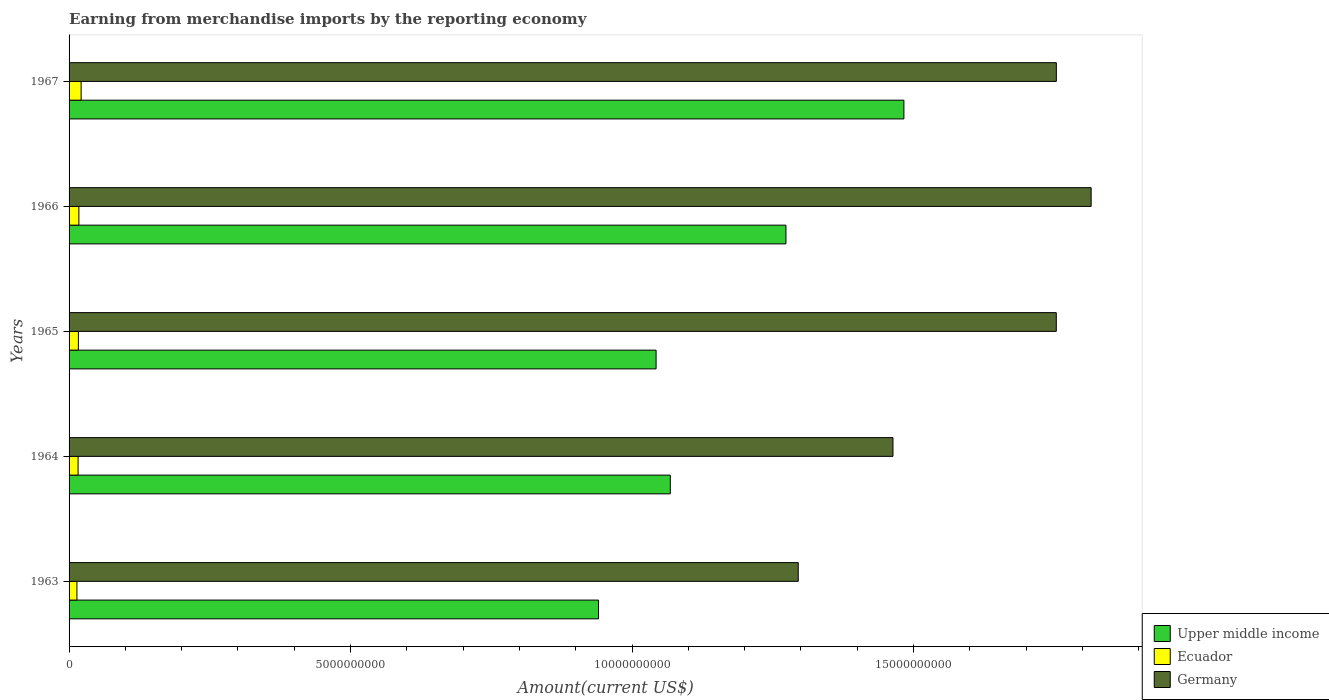How many different coloured bars are there?
Your response must be concise. 3. Are the number of bars per tick equal to the number of legend labels?
Provide a short and direct response. Yes. Are the number of bars on each tick of the Y-axis equal?
Offer a very short reply. Yes. How many bars are there on the 2nd tick from the top?
Provide a succinct answer. 3. How many bars are there on the 4th tick from the bottom?
Your answer should be compact. 3. What is the label of the 4th group of bars from the top?
Offer a very short reply. 1964. In how many cases, is the number of bars for a given year not equal to the number of legend labels?
Ensure brevity in your answer.  0. What is the amount earned from merchandise imports in Germany in 1966?
Your response must be concise. 1.82e+1. Across all years, what is the maximum amount earned from merchandise imports in Ecuador?
Make the answer very short. 2.14e+08. Across all years, what is the minimum amount earned from merchandise imports in Upper middle income?
Provide a succinct answer. 9.40e+09. In which year was the amount earned from merchandise imports in Ecuador maximum?
Your answer should be compact. 1967. In which year was the amount earned from merchandise imports in Upper middle income minimum?
Make the answer very short. 1963. What is the total amount earned from merchandise imports in Germany in the graph?
Offer a terse response. 8.08e+1. What is the difference between the amount earned from merchandise imports in Upper middle income in 1964 and that in 1966?
Offer a terse response. -2.05e+09. What is the difference between the amount earned from merchandise imports in Germany in 1966 and the amount earned from merchandise imports in Upper middle income in 1963?
Make the answer very short. 8.75e+09. What is the average amount earned from merchandise imports in Upper middle income per year?
Your answer should be very brief. 1.16e+1. In the year 1967, what is the difference between the amount earned from merchandise imports in Upper middle income and amount earned from merchandise imports in Ecuador?
Provide a short and direct response. 1.46e+1. In how many years, is the amount earned from merchandise imports in Germany greater than 8000000000 US$?
Make the answer very short. 5. What is the ratio of the amount earned from merchandise imports in Germany in 1963 to that in 1964?
Offer a terse response. 0.89. Is the amount earned from merchandise imports in Ecuador in 1964 less than that in 1966?
Provide a short and direct response. Yes. Is the difference between the amount earned from merchandise imports in Upper middle income in 1963 and 1964 greater than the difference between the amount earned from merchandise imports in Ecuador in 1963 and 1964?
Keep it short and to the point. No. What is the difference between the highest and the second highest amount earned from merchandise imports in Upper middle income?
Provide a succinct answer. 2.10e+09. What is the difference between the highest and the lowest amount earned from merchandise imports in Upper middle income?
Your response must be concise. 5.42e+09. Is the sum of the amount earned from merchandise imports in Germany in 1964 and 1965 greater than the maximum amount earned from merchandise imports in Upper middle income across all years?
Keep it short and to the point. Yes. What does the 3rd bar from the top in 1966 represents?
Your response must be concise. Upper middle income. What does the 3rd bar from the bottom in 1963 represents?
Offer a very short reply. Germany. Is it the case that in every year, the sum of the amount earned from merchandise imports in Ecuador and amount earned from merchandise imports in Germany is greater than the amount earned from merchandise imports in Upper middle income?
Ensure brevity in your answer.  Yes. Are all the bars in the graph horizontal?
Ensure brevity in your answer.  Yes. How many years are there in the graph?
Provide a succinct answer. 5. What is the difference between two consecutive major ticks on the X-axis?
Keep it short and to the point. 5.00e+09. How many legend labels are there?
Provide a succinct answer. 3. How are the legend labels stacked?
Offer a very short reply. Vertical. What is the title of the graph?
Provide a short and direct response. Earning from merchandise imports by the reporting economy. Does "Europe(all income levels)" appear as one of the legend labels in the graph?
Keep it short and to the point. No. What is the label or title of the X-axis?
Offer a very short reply. Amount(current US$). What is the label or title of the Y-axis?
Ensure brevity in your answer.  Years. What is the Amount(current US$) of Upper middle income in 1963?
Offer a terse response. 9.40e+09. What is the Amount(current US$) in Ecuador in 1963?
Offer a terse response. 1.39e+08. What is the Amount(current US$) in Germany in 1963?
Your answer should be very brief. 1.30e+1. What is the Amount(current US$) in Upper middle income in 1964?
Provide a succinct answer. 1.07e+1. What is the Amount(current US$) of Ecuador in 1964?
Your response must be concise. 1.60e+08. What is the Amount(current US$) in Germany in 1964?
Make the answer very short. 1.46e+1. What is the Amount(current US$) in Upper middle income in 1965?
Your response must be concise. 1.04e+1. What is the Amount(current US$) of Ecuador in 1965?
Give a very brief answer. 1.65e+08. What is the Amount(current US$) in Germany in 1965?
Provide a short and direct response. 1.75e+1. What is the Amount(current US$) in Upper middle income in 1966?
Offer a very short reply. 1.27e+1. What is the Amount(current US$) in Ecuador in 1966?
Ensure brevity in your answer.  1.74e+08. What is the Amount(current US$) of Germany in 1966?
Your response must be concise. 1.82e+1. What is the Amount(current US$) in Upper middle income in 1967?
Your answer should be compact. 1.48e+1. What is the Amount(current US$) of Ecuador in 1967?
Make the answer very short. 2.14e+08. What is the Amount(current US$) of Germany in 1967?
Provide a short and direct response. 1.75e+1. Across all years, what is the maximum Amount(current US$) in Upper middle income?
Your answer should be very brief. 1.48e+1. Across all years, what is the maximum Amount(current US$) in Ecuador?
Make the answer very short. 2.14e+08. Across all years, what is the maximum Amount(current US$) in Germany?
Your answer should be compact. 1.82e+1. Across all years, what is the minimum Amount(current US$) of Upper middle income?
Make the answer very short. 9.40e+09. Across all years, what is the minimum Amount(current US$) in Ecuador?
Offer a very short reply. 1.39e+08. Across all years, what is the minimum Amount(current US$) of Germany?
Provide a succinct answer. 1.30e+1. What is the total Amount(current US$) of Upper middle income in the graph?
Keep it short and to the point. 5.81e+1. What is the total Amount(current US$) in Ecuador in the graph?
Offer a very short reply. 8.53e+08. What is the total Amount(current US$) in Germany in the graph?
Make the answer very short. 8.08e+1. What is the difference between the Amount(current US$) of Upper middle income in 1963 and that in 1964?
Your response must be concise. -1.27e+09. What is the difference between the Amount(current US$) of Ecuador in 1963 and that in 1964?
Offer a terse response. -2.07e+07. What is the difference between the Amount(current US$) in Germany in 1963 and that in 1964?
Your answer should be compact. -1.68e+09. What is the difference between the Amount(current US$) in Upper middle income in 1963 and that in 1965?
Give a very brief answer. -1.02e+09. What is the difference between the Amount(current US$) in Ecuador in 1963 and that in 1965?
Provide a short and direct response. -2.60e+07. What is the difference between the Amount(current US$) of Germany in 1963 and that in 1965?
Your response must be concise. -4.58e+09. What is the difference between the Amount(current US$) in Upper middle income in 1963 and that in 1966?
Provide a succinct answer. -3.33e+09. What is the difference between the Amount(current US$) in Ecuador in 1963 and that in 1966?
Offer a very short reply. -3.48e+07. What is the difference between the Amount(current US$) in Germany in 1963 and that in 1966?
Keep it short and to the point. -5.20e+09. What is the difference between the Amount(current US$) of Upper middle income in 1963 and that in 1967?
Your response must be concise. -5.42e+09. What is the difference between the Amount(current US$) in Ecuador in 1963 and that in 1967?
Provide a succinct answer. -7.48e+07. What is the difference between the Amount(current US$) in Germany in 1963 and that in 1967?
Your response must be concise. -4.58e+09. What is the difference between the Amount(current US$) in Upper middle income in 1964 and that in 1965?
Your answer should be very brief. 2.52e+08. What is the difference between the Amount(current US$) of Ecuador in 1964 and that in 1965?
Offer a very short reply. -5.36e+06. What is the difference between the Amount(current US$) of Germany in 1964 and that in 1965?
Ensure brevity in your answer.  -2.90e+09. What is the difference between the Amount(current US$) in Upper middle income in 1964 and that in 1966?
Give a very brief answer. -2.05e+09. What is the difference between the Amount(current US$) in Ecuador in 1964 and that in 1966?
Offer a terse response. -1.41e+07. What is the difference between the Amount(current US$) in Germany in 1964 and that in 1966?
Ensure brevity in your answer.  -3.52e+09. What is the difference between the Amount(current US$) in Upper middle income in 1964 and that in 1967?
Give a very brief answer. -4.15e+09. What is the difference between the Amount(current US$) of Ecuador in 1964 and that in 1967?
Give a very brief answer. -5.42e+07. What is the difference between the Amount(current US$) of Germany in 1964 and that in 1967?
Offer a very short reply. -2.90e+09. What is the difference between the Amount(current US$) in Upper middle income in 1965 and that in 1966?
Offer a very short reply. -2.31e+09. What is the difference between the Amount(current US$) of Ecuador in 1965 and that in 1966?
Provide a succinct answer. -8.71e+06. What is the difference between the Amount(current US$) of Germany in 1965 and that in 1966?
Offer a terse response. -6.19e+08. What is the difference between the Amount(current US$) of Upper middle income in 1965 and that in 1967?
Provide a succinct answer. -4.40e+09. What is the difference between the Amount(current US$) of Ecuador in 1965 and that in 1967?
Offer a terse response. -4.88e+07. What is the difference between the Amount(current US$) in Germany in 1965 and that in 1967?
Offer a terse response. -1.00e+06. What is the difference between the Amount(current US$) in Upper middle income in 1966 and that in 1967?
Your answer should be compact. -2.10e+09. What is the difference between the Amount(current US$) of Ecuador in 1966 and that in 1967?
Ensure brevity in your answer.  -4.01e+07. What is the difference between the Amount(current US$) in Germany in 1966 and that in 1967?
Give a very brief answer. 6.18e+08. What is the difference between the Amount(current US$) in Upper middle income in 1963 and the Amount(current US$) in Ecuador in 1964?
Provide a succinct answer. 9.24e+09. What is the difference between the Amount(current US$) in Upper middle income in 1963 and the Amount(current US$) in Germany in 1964?
Your answer should be compact. -5.23e+09. What is the difference between the Amount(current US$) of Ecuador in 1963 and the Amount(current US$) of Germany in 1964?
Offer a terse response. -1.45e+1. What is the difference between the Amount(current US$) of Upper middle income in 1963 and the Amount(current US$) of Ecuador in 1965?
Your answer should be very brief. 9.24e+09. What is the difference between the Amount(current US$) of Upper middle income in 1963 and the Amount(current US$) of Germany in 1965?
Ensure brevity in your answer.  -8.13e+09. What is the difference between the Amount(current US$) in Ecuador in 1963 and the Amount(current US$) in Germany in 1965?
Your response must be concise. -1.74e+1. What is the difference between the Amount(current US$) of Upper middle income in 1963 and the Amount(current US$) of Ecuador in 1966?
Give a very brief answer. 9.23e+09. What is the difference between the Amount(current US$) in Upper middle income in 1963 and the Amount(current US$) in Germany in 1966?
Provide a succinct answer. -8.75e+09. What is the difference between the Amount(current US$) in Ecuador in 1963 and the Amount(current US$) in Germany in 1966?
Offer a very short reply. -1.80e+1. What is the difference between the Amount(current US$) of Upper middle income in 1963 and the Amount(current US$) of Ecuador in 1967?
Your response must be concise. 9.19e+09. What is the difference between the Amount(current US$) in Upper middle income in 1963 and the Amount(current US$) in Germany in 1967?
Make the answer very short. -8.13e+09. What is the difference between the Amount(current US$) of Ecuador in 1963 and the Amount(current US$) of Germany in 1967?
Offer a very short reply. -1.74e+1. What is the difference between the Amount(current US$) of Upper middle income in 1964 and the Amount(current US$) of Ecuador in 1965?
Offer a terse response. 1.05e+1. What is the difference between the Amount(current US$) in Upper middle income in 1964 and the Amount(current US$) in Germany in 1965?
Offer a terse response. -6.86e+09. What is the difference between the Amount(current US$) in Ecuador in 1964 and the Amount(current US$) in Germany in 1965?
Provide a succinct answer. -1.74e+1. What is the difference between the Amount(current US$) in Upper middle income in 1964 and the Amount(current US$) in Ecuador in 1966?
Provide a succinct answer. 1.05e+1. What is the difference between the Amount(current US$) of Upper middle income in 1964 and the Amount(current US$) of Germany in 1966?
Your answer should be compact. -7.48e+09. What is the difference between the Amount(current US$) of Ecuador in 1964 and the Amount(current US$) of Germany in 1966?
Make the answer very short. -1.80e+1. What is the difference between the Amount(current US$) of Upper middle income in 1964 and the Amount(current US$) of Ecuador in 1967?
Provide a succinct answer. 1.05e+1. What is the difference between the Amount(current US$) of Upper middle income in 1964 and the Amount(current US$) of Germany in 1967?
Offer a terse response. -6.86e+09. What is the difference between the Amount(current US$) in Ecuador in 1964 and the Amount(current US$) in Germany in 1967?
Ensure brevity in your answer.  -1.74e+1. What is the difference between the Amount(current US$) of Upper middle income in 1965 and the Amount(current US$) of Ecuador in 1966?
Provide a succinct answer. 1.03e+1. What is the difference between the Amount(current US$) of Upper middle income in 1965 and the Amount(current US$) of Germany in 1966?
Offer a terse response. -7.73e+09. What is the difference between the Amount(current US$) of Ecuador in 1965 and the Amount(current US$) of Germany in 1966?
Make the answer very short. -1.80e+1. What is the difference between the Amount(current US$) of Upper middle income in 1965 and the Amount(current US$) of Ecuador in 1967?
Provide a short and direct response. 1.02e+1. What is the difference between the Amount(current US$) of Upper middle income in 1965 and the Amount(current US$) of Germany in 1967?
Make the answer very short. -7.11e+09. What is the difference between the Amount(current US$) of Ecuador in 1965 and the Amount(current US$) of Germany in 1967?
Make the answer very short. -1.74e+1. What is the difference between the Amount(current US$) of Upper middle income in 1966 and the Amount(current US$) of Ecuador in 1967?
Give a very brief answer. 1.25e+1. What is the difference between the Amount(current US$) of Upper middle income in 1966 and the Amount(current US$) of Germany in 1967?
Your response must be concise. -4.80e+09. What is the difference between the Amount(current US$) in Ecuador in 1966 and the Amount(current US$) in Germany in 1967?
Offer a terse response. -1.74e+1. What is the average Amount(current US$) in Upper middle income per year?
Make the answer very short. 1.16e+1. What is the average Amount(current US$) in Ecuador per year?
Your response must be concise. 1.71e+08. What is the average Amount(current US$) of Germany per year?
Your answer should be very brief. 1.62e+1. In the year 1963, what is the difference between the Amount(current US$) in Upper middle income and Amount(current US$) in Ecuador?
Ensure brevity in your answer.  9.27e+09. In the year 1963, what is the difference between the Amount(current US$) of Upper middle income and Amount(current US$) of Germany?
Give a very brief answer. -3.55e+09. In the year 1963, what is the difference between the Amount(current US$) in Ecuador and Amount(current US$) in Germany?
Offer a terse response. -1.28e+1. In the year 1964, what is the difference between the Amount(current US$) in Upper middle income and Amount(current US$) in Ecuador?
Make the answer very short. 1.05e+1. In the year 1964, what is the difference between the Amount(current US$) in Upper middle income and Amount(current US$) in Germany?
Your answer should be very brief. -3.96e+09. In the year 1964, what is the difference between the Amount(current US$) of Ecuador and Amount(current US$) of Germany?
Ensure brevity in your answer.  -1.45e+1. In the year 1965, what is the difference between the Amount(current US$) of Upper middle income and Amount(current US$) of Ecuador?
Provide a succinct answer. 1.03e+1. In the year 1965, what is the difference between the Amount(current US$) in Upper middle income and Amount(current US$) in Germany?
Ensure brevity in your answer.  -7.11e+09. In the year 1965, what is the difference between the Amount(current US$) in Ecuador and Amount(current US$) in Germany?
Your answer should be very brief. -1.74e+1. In the year 1966, what is the difference between the Amount(current US$) of Upper middle income and Amount(current US$) of Ecuador?
Provide a short and direct response. 1.26e+1. In the year 1966, what is the difference between the Amount(current US$) in Upper middle income and Amount(current US$) in Germany?
Offer a very short reply. -5.42e+09. In the year 1966, what is the difference between the Amount(current US$) of Ecuador and Amount(current US$) of Germany?
Your answer should be compact. -1.80e+1. In the year 1967, what is the difference between the Amount(current US$) in Upper middle income and Amount(current US$) in Ecuador?
Keep it short and to the point. 1.46e+1. In the year 1967, what is the difference between the Amount(current US$) of Upper middle income and Amount(current US$) of Germany?
Offer a very short reply. -2.71e+09. In the year 1967, what is the difference between the Amount(current US$) in Ecuador and Amount(current US$) in Germany?
Give a very brief answer. -1.73e+1. What is the ratio of the Amount(current US$) in Upper middle income in 1963 to that in 1964?
Offer a terse response. 0.88. What is the ratio of the Amount(current US$) of Ecuador in 1963 to that in 1964?
Ensure brevity in your answer.  0.87. What is the ratio of the Amount(current US$) in Germany in 1963 to that in 1964?
Offer a very short reply. 0.89. What is the ratio of the Amount(current US$) of Upper middle income in 1963 to that in 1965?
Ensure brevity in your answer.  0.9. What is the ratio of the Amount(current US$) in Ecuador in 1963 to that in 1965?
Your answer should be compact. 0.84. What is the ratio of the Amount(current US$) of Germany in 1963 to that in 1965?
Provide a succinct answer. 0.74. What is the ratio of the Amount(current US$) in Upper middle income in 1963 to that in 1966?
Offer a very short reply. 0.74. What is the ratio of the Amount(current US$) in Ecuador in 1963 to that in 1966?
Ensure brevity in your answer.  0.8. What is the ratio of the Amount(current US$) in Germany in 1963 to that in 1966?
Give a very brief answer. 0.71. What is the ratio of the Amount(current US$) in Upper middle income in 1963 to that in 1967?
Give a very brief answer. 0.63. What is the ratio of the Amount(current US$) in Ecuador in 1963 to that in 1967?
Ensure brevity in your answer.  0.65. What is the ratio of the Amount(current US$) of Germany in 1963 to that in 1967?
Keep it short and to the point. 0.74. What is the ratio of the Amount(current US$) in Upper middle income in 1964 to that in 1965?
Offer a very short reply. 1.02. What is the ratio of the Amount(current US$) of Ecuador in 1964 to that in 1965?
Your response must be concise. 0.97. What is the ratio of the Amount(current US$) in Germany in 1964 to that in 1965?
Your answer should be compact. 0.83. What is the ratio of the Amount(current US$) of Upper middle income in 1964 to that in 1966?
Your response must be concise. 0.84. What is the ratio of the Amount(current US$) of Ecuador in 1964 to that in 1966?
Give a very brief answer. 0.92. What is the ratio of the Amount(current US$) of Germany in 1964 to that in 1966?
Keep it short and to the point. 0.81. What is the ratio of the Amount(current US$) of Upper middle income in 1964 to that in 1967?
Offer a terse response. 0.72. What is the ratio of the Amount(current US$) in Ecuador in 1964 to that in 1967?
Ensure brevity in your answer.  0.75. What is the ratio of the Amount(current US$) in Germany in 1964 to that in 1967?
Offer a very short reply. 0.83. What is the ratio of the Amount(current US$) in Upper middle income in 1965 to that in 1966?
Your response must be concise. 0.82. What is the ratio of the Amount(current US$) in Ecuador in 1965 to that in 1966?
Give a very brief answer. 0.95. What is the ratio of the Amount(current US$) in Germany in 1965 to that in 1966?
Provide a short and direct response. 0.97. What is the ratio of the Amount(current US$) of Upper middle income in 1965 to that in 1967?
Ensure brevity in your answer.  0.7. What is the ratio of the Amount(current US$) in Ecuador in 1965 to that in 1967?
Provide a succinct answer. 0.77. What is the ratio of the Amount(current US$) in Germany in 1965 to that in 1967?
Offer a very short reply. 1. What is the ratio of the Amount(current US$) of Upper middle income in 1966 to that in 1967?
Provide a succinct answer. 0.86. What is the ratio of the Amount(current US$) of Ecuador in 1966 to that in 1967?
Your answer should be compact. 0.81. What is the ratio of the Amount(current US$) of Germany in 1966 to that in 1967?
Your answer should be very brief. 1.04. What is the difference between the highest and the second highest Amount(current US$) in Upper middle income?
Your response must be concise. 2.10e+09. What is the difference between the highest and the second highest Amount(current US$) of Ecuador?
Provide a succinct answer. 4.01e+07. What is the difference between the highest and the second highest Amount(current US$) in Germany?
Keep it short and to the point. 6.18e+08. What is the difference between the highest and the lowest Amount(current US$) of Upper middle income?
Keep it short and to the point. 5.42e+09. What is the difference between the highest and the lowest Amount(current US$) in Ecuador?
Keep it short and to the point. 7.48e+07. What is the difference between the highest and the lowest Amount(current US$) of Germany?
Your response must be concise. 5.20e+09. 